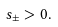Convert formula to latex. <formula><loc_0><loc_0><loc_500><loc_500>s _ { \pm } > 0 .</formula> 